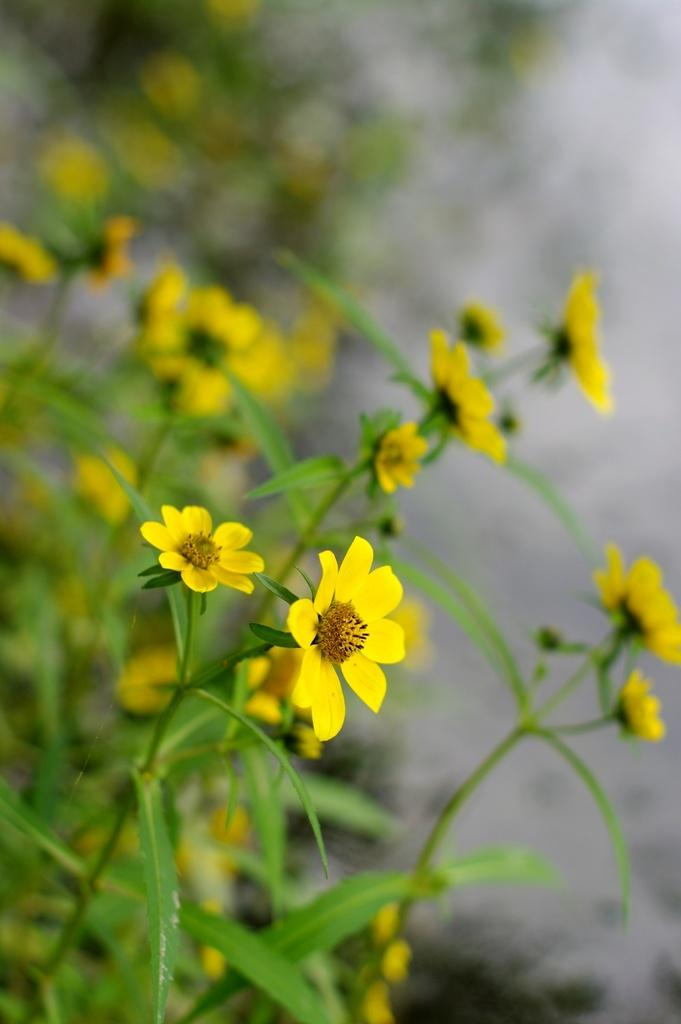What type of plant life can be seen in the image? There are leaves and flowers in the image. Can you describe the background of the image? The background of the image is blurry. What type of shoe can be seen in the image? There is no shoe present in the image; it features leaves and flowers with a blurry background. 